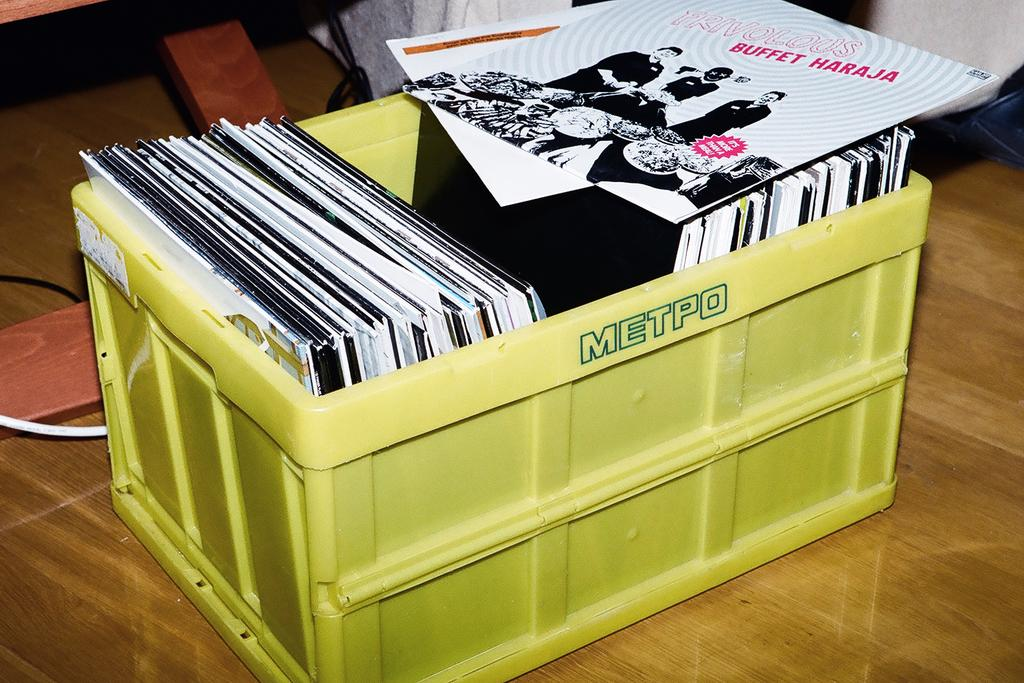Provide a one-sentence caption for the provided image. a box of records with the word Metpo on it. 